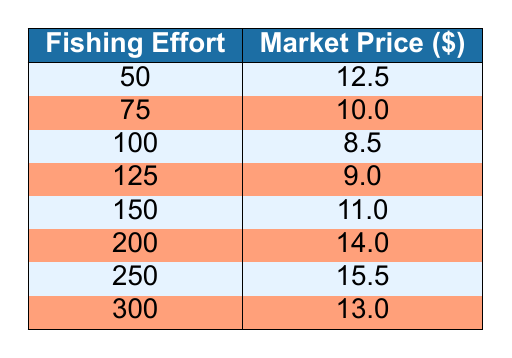What is the market price when the fishing effort is 50? According to the table, when the fishing effort is 50, the corresponding market price listed is 12.5.
Answer: 12.5 What fishing effort corresponds to a market price of 14.0? The table shows that a market price of 14.0 corresponds to a fishing effort of 200.
Answer: 200 What is the average market price across all fishing efforts listed? To calculate the average market price, sum the prices: (12.5 + 10.0 + 8.5 + 9.0 + 11.0 + 14.0 + 15.5 + 13.0) = 99.5. There are 8 data points, so the average is 99.5 / 8 = 12.4375.
Answer: 12.44 Is there a fishing effort of 300 with a market price lower than 10? Checking the table, the fishing effort of 300 has a market price of 13.0, which is higher than 10.
Answer: No Which fishing effort has the lowest market price and what is that price? The lowest market price listed in the table is 8.5, which corresponds to a fishing effort of 100.
Answer: 100, 8.5 What is the difference in market price between a fishing effort of 250 and 200? The market price for a fishing effort of 250 is 15.5, while for 200 it is 14.0. The difference is 15.5 - 14.0 = 1.5.
Answer: 1.5 Does increasing fishing effort always lead to a higher market price? Examining the table, we see that an increase from 100 (8.5) to 125 (9.0) increases the price, but then at 150 (11.0), and 200 (14.0) subsequent efforts result in fluctuations before a drop at 300 (13.0). This indicates that increases in fishing effort do not always result in higher prices.
Answer: No What market price is recorded for a fishing effort of 150? According to the table, the market price for a fishing effort of 150 is 11.0.
Answer: 11.0 